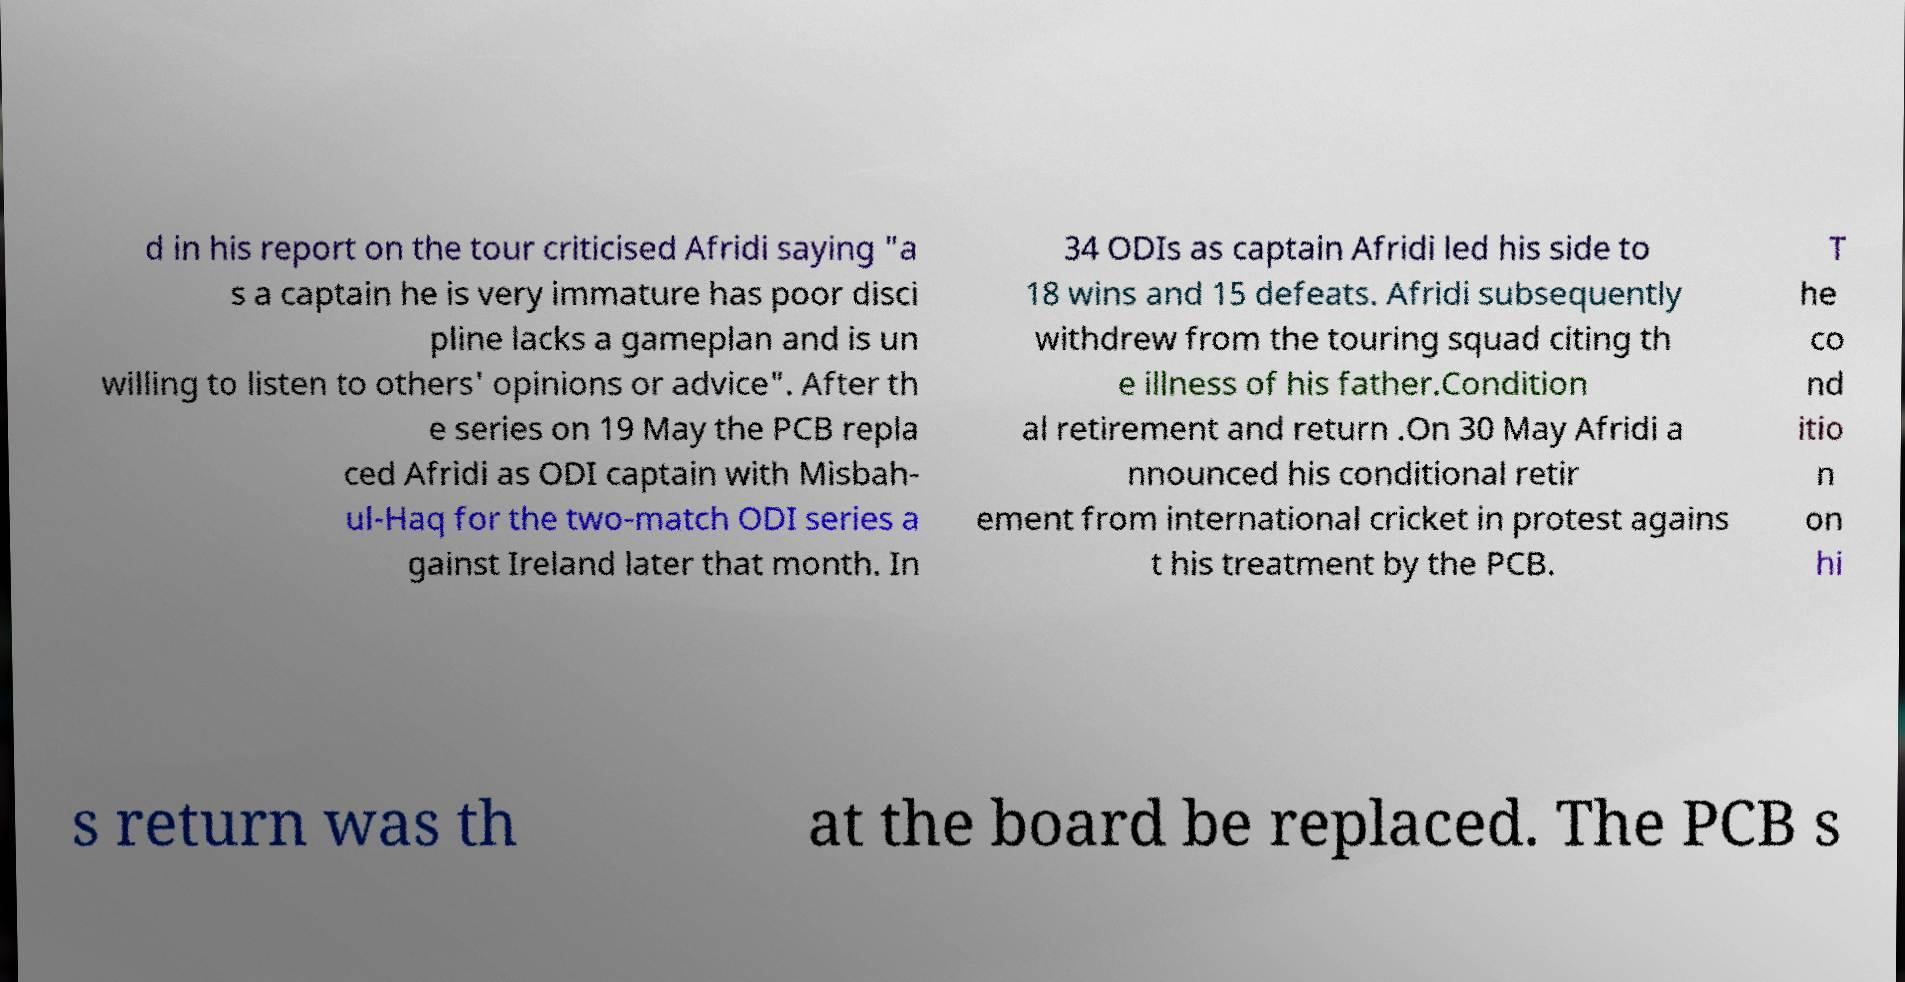Can you read and provide the text displayed in the image?This photo seems to have some interesting text. Can you extract and type it out for me? d in his report on the tour criticised Afridi saying "a s a captain he is very immature has poor disci pline lacks a gameplan and is un willing to listen to others' opinions or advice". After th e series on 19 May the PCB repla ced Afridi as ODI captain with Misbah- ul-Haq for the two-match ODI series a gainst Ireland later that month. In 34 ODIs as captain Afridi led his side to 18 wins and 15 defeats. Afridi subsequently withdrew from the touring squad citing th e illness of his father.Condition al retirement and return .On 30 May Afridi a nnounced his conditional retir ement from international cricket in protest agains t his treatment by the PCB. T he co nd itio n on hi s return was th at the board be replaced. The PCB s 